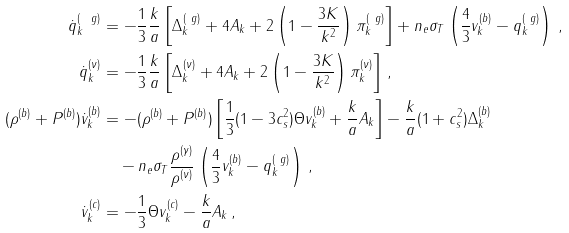<formula> <loc_0><loc_0><loc_500><loc_500>\dot { q } ^ { ( \ g ) } _ { k } & = - \frac { 1 } { 3 } \frac { k } { a } \left [ \Delta ^ { ( \ g ) } _ { k } + 4 A _ { k } + 2 \left ( 1 - \frac { 3 K } { k ^ { 2 } } \right ) \pi ^ { ( \ g ) } _ { k } \right ] + n _ { e } \sigma _ { T } \left ( \frac { 4 } { 3 } v ^ { ( b ) } _ { k } - q ^ { ( \ g ) } _ { k } \right ) \, , \\ \dot { q } ^ { ( \nu ) } _ { k } & = - \frac { 1 } { 3 } \frac { k } { a } \left [ \Delta ^ { ( \nu ) } _ { k } + 4 A _ { k } + 2 \left ( 1 - \frac { 3 K } { k ^ { 2 } } \right ) \pi ^ { ( \nu ) } _ { k } \right ] \, , \\ ( \rho ^ { ( b ) } + P ^ { ( b ) } ) \dot { v } ^ { ( b ) } _ { k } & = - ( \rho ^ { ( b ) } + P ^ { ( b ) } ) \left [ \frac { 1 } { 3 } ( 1 - 3 c _ { s } ^ { 2 } ) \Theta v ^ { ( b ) } _ { k } + \frac { k } { a } A _ { k } \right ] - \frac { k } { a } ( 1 + c _ { s } ^ { 2 } ) \Delta ^ { ( b ) } _ { k } \\ & \quad - n _ { e } \sigma _ { T } \frac { \rho ^ { ( \gamma ) } } { \rho ^ { ( \nu ) } } \left ( \frac { 4 } { 3 } v ^ { ( b ) } _ { k } - q ^ { ( \ g ) } _ { k } \right ) \, , \\ \dot { v } ^ { ( c ) } _ { k } & = - \frac { 1 } { 3 } \Theta v ^ { ( c ) } _ { k } - \frac { k } { a } A _ { k } \, ,</formula> 